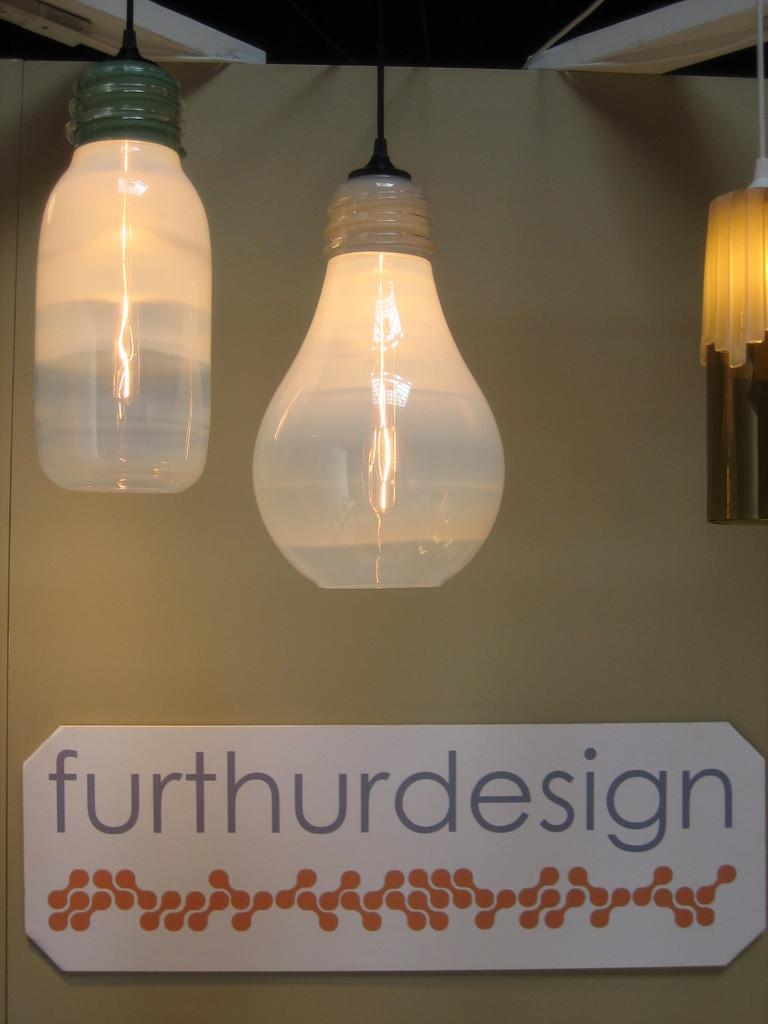What is the name of the designer?
Your answer should be very brief. Furthurdesign. 